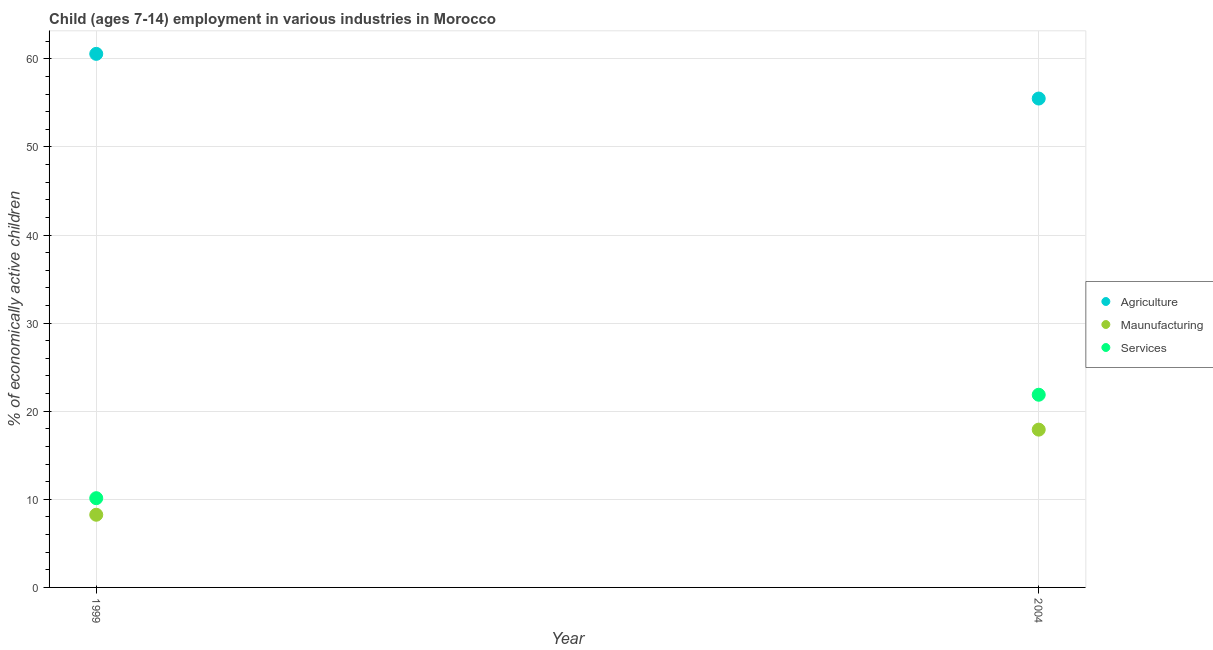How many different coloured dotlines are there?
Ensure brevity in your answer.  3. What is the percentage of economically active children in agriculture in 1999?
Provide a short and direct response. 60.56. Across all years, what is the maximum percentage of economically active children in services?
Keep it short and to the point. 21.87. Across all years, what is the minimum percentage of economically active children in agriculture?
Provide a succinct answer. 55.49. In which year was the percentage of economically active children in manufacturing minimum?
Offer a terse response. 1999. What is the total percentage of economically active children in agriculture in the graph?
Offer a terse response. 116.05. What is the difference between the percentage of economically active children in manufacturing in 1999 and that in 2004?
Your answer should be compact. -9.66. What is the difference between the percentage of economically active children in manufacturing in 1999 and the percentage of economically active children in services in 2004?
Your answer should be compact. -13.62. What is the average percentage of economically active children in manufacturing per year?
Provide a short and direct response. 13.08. In the year 2004, what is the difference between the percentage of economically active children in services and percentage of economically active children in agriculture?
Your answer should be compact. -33.62. What is the ratio of the percentage of economically active children in services in 1999 to that in 2004?
Ensure brevity in your answer.  0.46. Is the percentage of economically active children in services in 1999 less than that in 2004?
Your response must be concise. Yes. In how many years, is the percentage of economically active children in services greater than the average percentage of economically active children in services taken over all years?
Offer a terse response. 1. Does the percentage of economically active children in services monotonically increase over the years?
Ensure brevity in your answer.  Yes. Is the percentage of economically active children in manufacturing strictly less than the percentage of economically active children in agriculture over the years?
Ensure brevity in your answer.  Yes. How many dotlines are there?
Offer a terse response. 3. Are the values on the major ticks of Y-axis written in scientific E-notation?
Give a very brief answer. No. Where does the legend appear in the graph?
Ensure brevity in your answer.  Center right. How many legend labels are there?
Give a very brief answer. 3. What is the title of the graph?
Provide a short and direct response. Child (ages 7-14) employment in various industries in Morocco. Does "Oil" appear as one of the legend labels in the graph?
Provide a succinct answer. No. What is the label or title of the X-axis?
Provide a succinct answer. Year. What is the label or title of the Y-axis?
Ensure brevity in your answer.  % of economically active children. What is the % of economically active children in Agriculture in 1999?
Give a very brief answer. 60.56. What is the % of economically active children in Maunufacturing in 1999?
Provide a succinct answer. 8.25. What is the % of economically active children in Services in 1999?
Your answer should be compact. 10.13. What is the % of economically active children in Agriculture in 2004?
Your answer should be compact. 55.49. What is the % of economically active children of Maunufacturing in 2004?
Provide a succinct answer. 17.91. What is the % of economically active children of Services in 2004?
Provide a succinct answer. 21.87. Across all years, what is the maximum % of economically active children of Agriculture?
Provide a short and direct response. 60.56. Across all years, what is the maximum % of economically active children in Maunufacturing?
Your answer should be very brief. 17.91. Across all years, what is the maximum % of economically active children in Services?
Your answer should be compact. 21.87. Across all years, what is the minimum % of economically active children in Agriculture?
Your answer should be very brief. 55.49. Across all years, what is the minimum % of economically active children of Maunufacturing?
Your response must be concise. 8.25. Across all years, what is the minimum % of economically active children in Services?
Make the answer very short. 10.13. What is the total % of economically active children in Agriculture in the graph?
Make the answer very short. 116.05. What is the total % of economically active children of Maunufacturing in the graph?
Your answer should be very brief. 26.16. What is the total % of economically active children in Services in the graph?
Give a very brief answer. 32. What is the difference between the % of economically active children in Agriculture in 1999 and that in 2004?
Provide a succinct answer. 5.07. What is the difference between the % of economically active children in Maunufacturing in 1999 and that in 2004?
Provide a succinct answer. -9.66. What is the difference between the % of economically active children in Services in 1999 and that in 2004?
Provide a succinct answer. -11.74. What is the difference between the % of economically active children in Agriculture in 1999 and the % of economically active children in Maunufacturing in 2004?
Ensure brevity in your answer.  42.65. What is the difference between the % of economically active children in Agriculture in 1999 and the % of economically active children in Services in 2004?
Your answer should be compact. 38.69. What is the difference between the % of economically active children of Maunufacturing in 1999 and the % of economically active children of Services in 2004?
Provide a succinct answer. -13.62. What is the average % of economically active children in Agriculture per year?
Give a very brief answer. 58.02. What is the average % of economically active children in Maunufacturing per year?
Your response must be concise. 13.08. What is the average % of economically active children in Services per year?
Your response must be concise. 16. In the year 1999, what is the difference between the % of economically active children of Agriculture and % of economically active children of Maunufacturing?
Your answer should be compact. 52.31. In the year 1999, what is the difference between the % of economically active children of Agriculture and % of economically active children of Services?
Your answer should be compact. 50.43. In the year 1999, what is the difference between the % of economically active children in Maunufacturing and % of economically active children in Services?
Offer a very short reply. -1.88. In the year 2004, what is the difference between the % of economically active children of Agriculture and % of economically active children of Maunufacturing?
Provide a succinct answer. 37.58. In the year 2004, what is the difference between the % of economically active children of Agriculture and % of economically active children of Services?
Offer a terse response. 33.62. In the year 2004, what is the difference between the % of economically active children in Maunufacturing and % of economically active children in Services?
Give a very brief answer. -3.96. What is the ratio of the % of economically active children of Agriculture in 1999 to that in 2004?
Your response must be concise. 1.09. What is the ratio of the % of economically active children of Maunufacturing in 1999 to that in 2004?
Ensure brevity in your answer.  0.46. What is the ratio of the % of economically active children in Services in 1999 to that in 2004?
Offer a terse response. 0.46. What is the difference between the highest and the second highest % of economically active children in Agriculture?
Keep it short and to the point. 5.07. What is the difference between the highest and the second highest % of economically active children of Maunufacturing?
Make the answer very short. 9.66. What is the difference between the highest and the second highest % of economically active children in Services?
Offer a very short reply. 11.74. What is the difference between the highest and the lowest % of economically active children in Agriculture?
Your answer should be very brief. 5.07. What is the difference between the highest and the lowest % of economically active children in Maunufacturing?
Offer a very short reply. 9.66. What is the difference between the highest and the lowest % of economically active children in Services?
Provide a succinct answer. 11.74. 